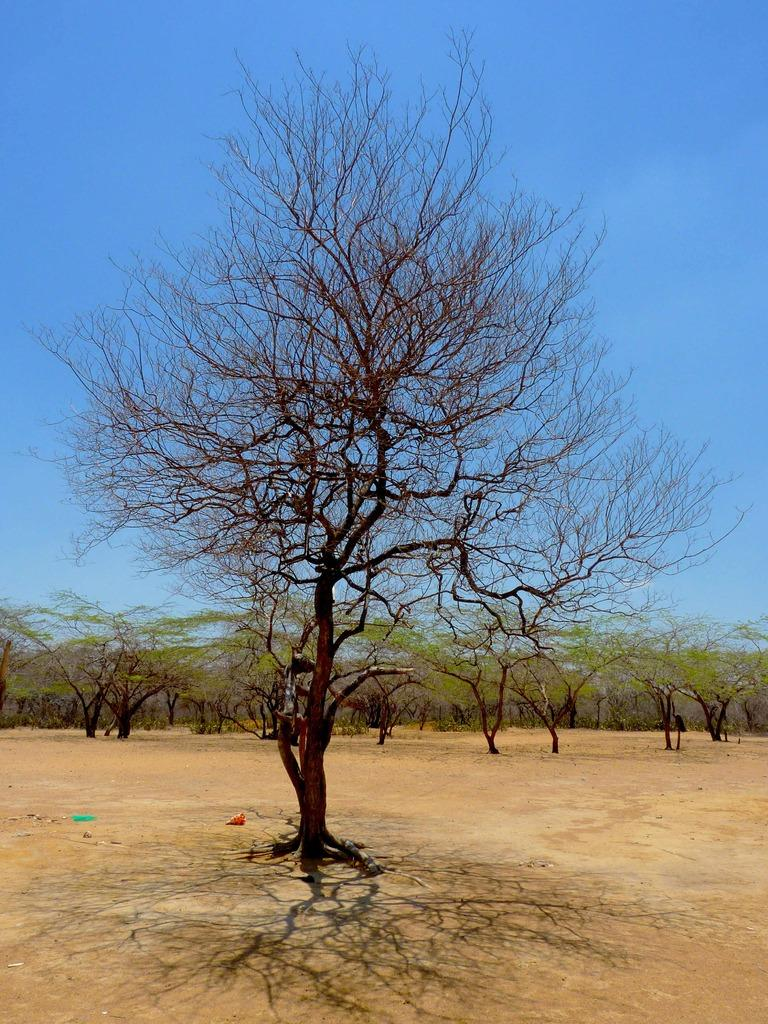What type of vegetation can be seen in the image? There are trees visible in the image. What is the surface on which the trees are located? The trees are on a surface. What else is visible in the image besides the trees? The sky is visible in the image. What type of appliance is generating profit in the image? There is no appliance generating profit in the image; it features trees and the sky. What type of food is being prepared in the image? There is no food preparation visible in the image; it features trees and the sky. 